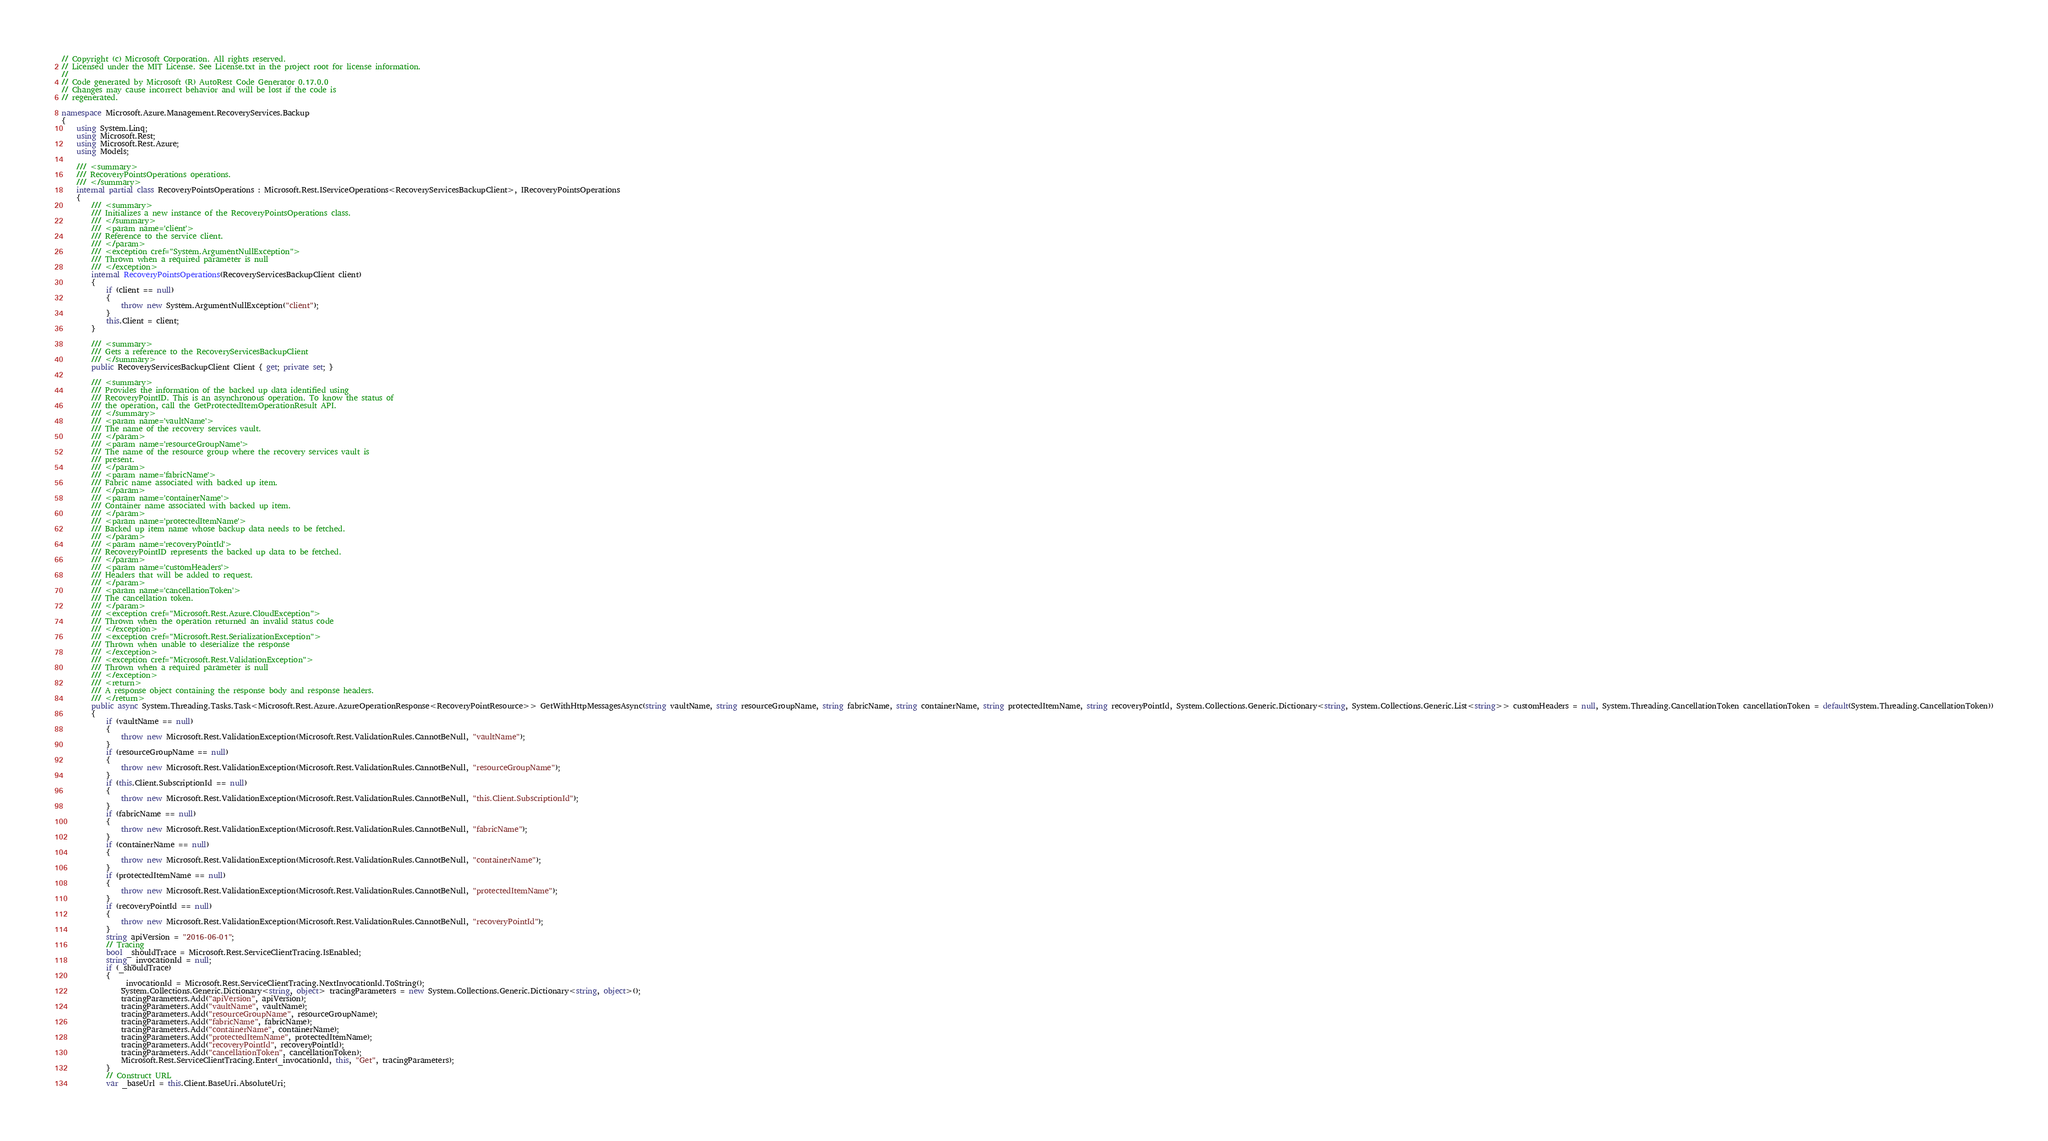<code> <loc_0><loc_0><loc_500><loc_500><_C#_>// Copyright (c) Microsoft Corporation. All rights reserved.
// Licensed under the MIT License. See License.txt in the project root for license information.
//
// Code generated by Microsoft (R) AutoRest Code Generator 0.17.0.0
// Changes may cause incorrect behavior and will be lost if the code is
// regenerated.

namespace Microsoft.Azure.Management.RecoveryServices.Backup
{
    using System.Linq;
    using Microsoft.Rest;
    using Microsoft.Rest.Azure;
    using Models;

    /// <summary>
    /// RecoveryPointsOperations operations.
    /// </summary>
    internal partial class RecoveryPointsOperations : Microsoft.Rest.IServiceOperations<RecoveryServicesBackupClient>, IRecoveryPointsOperations
    {
        /// <summary>
        /// Initializes a new instance of the RecoveryPointsOperations class.
        /// </summary>
        /// <param name='client'>
        /// Reference to the service client.
        /// </param>
        /// <exception cref="System.ArgumentNullException">
        /// Thrown when a required parameter is null
        /// </exception>
        internal RecoveryPointsOperations(RecoveryServicesBackupClient client)
        {
            if (client == null) 
            {
                throw new System.ArgumentNullException("client");
            }
            this.Client = client;
        }

        /// <summary>
        /// Gets a reference to the RecoveryServicesBackupClient
        /// </summary>
        public RecoveryServicesBackupClient Client { get; private set; }

        /// <summary>
        /// Provides the information of the backed up data identified using
        /// RecoveryPointID. This is an asynchronous operation. To know the status of
        /// the operation, call the GetProtectedItemOperationResult API.
        /// </summary>
        /// <param name='vaultName'>
        /// The name of the recovery services vault.
        /// </param>
        /// <param name='resourceGroupName'>
        /// The name of the resource group where the recovery services vault is
        /// present.
        /// </param>
        /// <param name='fabricName'>
        /// Fabric name associated with backed up item.
        /// </param>
        /// <param name='containerName'>
        /// Container name associated with backed up item.
        /// </param>
        /// <param name='protectedItemName'>
        /// Backed up item name whose backup data needs to be fetched.
        /// </param>
        /// <param name='recoveryPointId'>
        /// RecoveryPointID represents the backed up data to be fetched.
        /// </param>
        /// <param name='customHeaders'>
        /// Headers that will be added to request.
        /// </param>
        /// <param name='cancellationToken'>
        /// The cancellation token.
        /// </param>
        /// <exception cref="Microsoft.Rest.Azure.CloudException">
        /// Thrown when the operation returned an invalid status code
        /// </exception>
        /// <exception cref="Microsoft.Rest.SerializationException">
        /// Thrown when unable to deserialize the response
        /// </exception>
        /// <exception cref="Microsoft.Rest.ValidationException">
        /// Thrown when a required parameter is null
        /// </exception>
        /// <return>
        /// A response object containing the response body and response headers.
        /// </return>
        public async System.Threading.Tasks.Task<Microsoft.Rest.Azure.AzureOperationResponse<RecoveryPointResource>> GetWithHttpMessagesAsync(string vaultName, string resourceGroupName, string fabricName, string containerName, string protectedItemName, string recoveryPointId, System.Collections.Generic.Dictionary<string, System.Collections.Generic.List<string>> customHeaders = null, System.Threading.CancellationToken cancellationToken = default(System.Threading.CancellationToken))
        {
            if (vaultName == null)
            {
                throw new Microsoft.Rest.ValidationException(Microsoft.Rest.ValidationRules.CannotBeNull, "vaultName");
            }
            if (resourceGroupName == null)
            {
                throw new Microsoft.Rest.ValidationException(Microsoft.Rest.ValidationRules.CannotBeNull, "resourceGroupName");
            }
            if (this.Client.SubscriptionId == null)
            {
                throw new Microsoft.Rest.ValidationException(Microsoft.Rest.ValidationRules.CannotBeNull, "this.Client.SubscriptionId");
            }
            if (fabricName == null)
            {
                throw new Microsoft.Rest.ValidationException(Microsoft.Rest.ValidationRules.CannotBeNull, "fabricName");
            }
            if (containerName == null)
            {
                throw new Microsoft.Rest.ValidationException(Microsoft.Rest.ValidationRules.CannotBeNull, "containerName");
            }
            if (protectedItemName == null)
            {
                throw new Microsoft.Rest.ValidationException(Microsoft.Rest.ValidationRules.CannotBeNull, "protectedItemName");
            }
            if (recoveryPointId == null)
            {
                throw new Microsoft.Rest.ValidationException(Microsoft.Rest.ValidationRules.CannotBeNull, "recoveryPointId");
            }
            string apiVersion = "2016-06-01";
            // Tracing
            bool _shouldTrace = Microsoft.Rest.ServiceClientTracing.IsEnabled;
            string _invocationId = null;
            if (_shouldTrace)
            {
                _invocationId = Microsoft.Rest.ServiceClientTracing.NextInvocationId.ToString();
                System.Collections.Generic.Dictionary<string, object> tracingParameters = new System.Collections.Generic.Dictionary<string, object>();
                tracingParameters.Add("apiVersion", apiVersion);
                tracingParameters.Add("vaultName", vaultName);
                tracingParameters.Add("resourceGroupName", resourceGroupName);
                tracingParameters.Add("fabricName", fabricName);
                tracingParameters.Add("containerName", containerName);
                tracingParameters.Add("protectedItemName", protectedItemName);
                tracingParameters.Add("recoveryPointId", recoveryPointId);
                tracingParameters.Add("cancellationToken", cancellationToken);
                Microsoft.Rest.ServiceClientTracing.Enter(_invocationId, this, "Get", tracingParameters);
            }
            // Construct URL
            var _baseUrl = this.Client.BaseUri.AbsoluteUri;</code> 